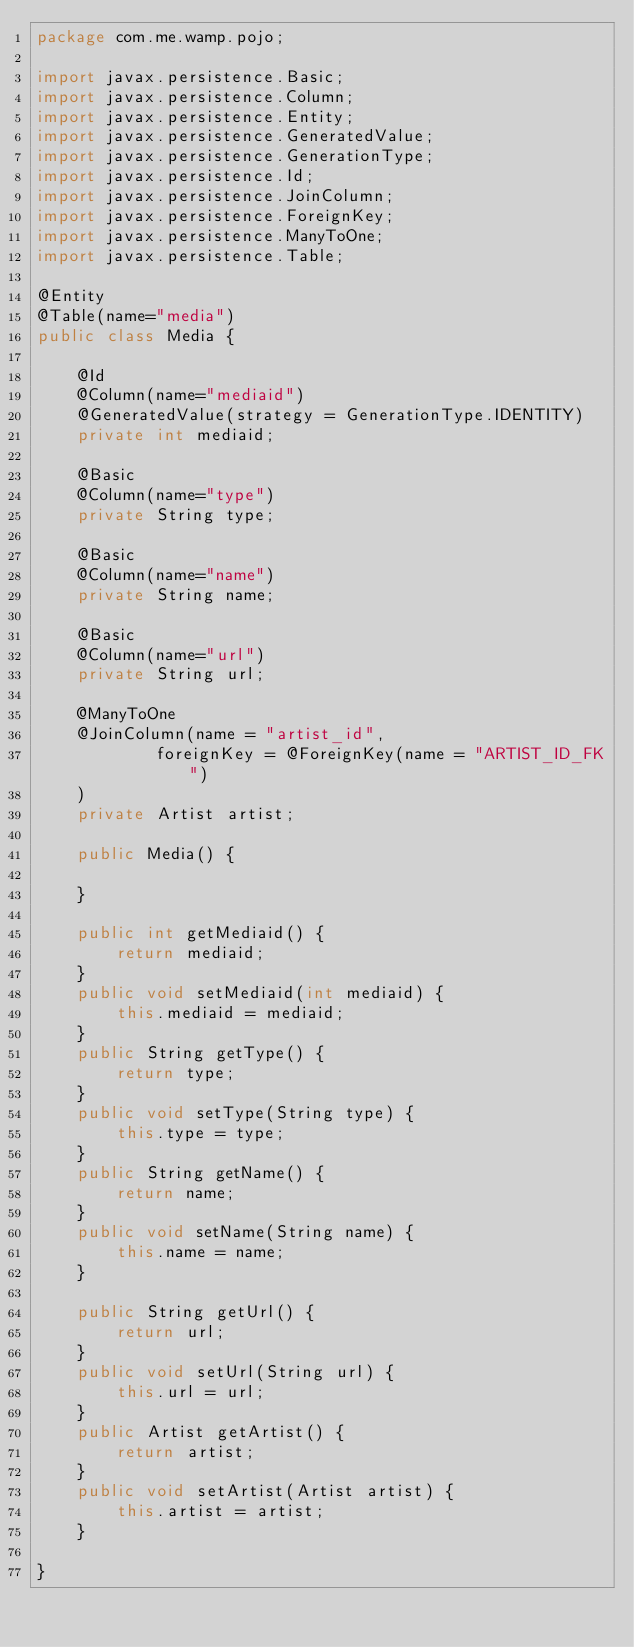<code> <loc_0><loc_0><loc_500><loc_500><_Java_>package com.me.wamp.pojo;

import javax.persistence.Basic;
import javax.persistence.Column;
import javax.persistence.Entity;
import javax.persistence.GeneratedValue;
import javax.persistence.GenerationType;
import javax.persistence.Id;
import javax.persistence.JoinColumn;
import javax.persistence.ForeignKey;
import javax.persistence.ManyToOne;
import javax.persistence.Table;

@Entity
@Table(name="media")
public class Media {
	
	@Id
	@Column(name="mediaid")
	@GeneratedValue(strategy = GenerationType.IDENTITY)
	private int mediaid;
	
	@Basic
	@Column(name="type")
	private String type;
	
	@Basic
	@Column(name="name")
	private String name;
	
	@Basic
	@Column(name="url")
	private String url;
	
	@ManyToOne
	@JoinColumn(name = "artist_id",
			foreignKey = @ForeignKey(name = "ARTIST_ID_FK")
	)
	private Artist artist;
	
	public Media() {
		
	}
	
	public int getMediaid() {
		return mediaid;
	}
	public void setMediaid(int mediaid) {
		this.mediaid = mediaid;
	}
	public String getType() {
		return type;
	}
	public void setType(String type) {
		this.type = type;
	}
	public String getName() {
		return name;
	}
	public void setName(String name) {
		this.name = name;
	}
	
	public String getUrl() {
		return url;
	}
	public void setUrl(String url) {
		this.url = url;
	}
	public Artist getArtist() {
		return artist;
	}
	public void setArtist(Artist artist) {
		this.artist = artist;
	}
	 
}
</code> 